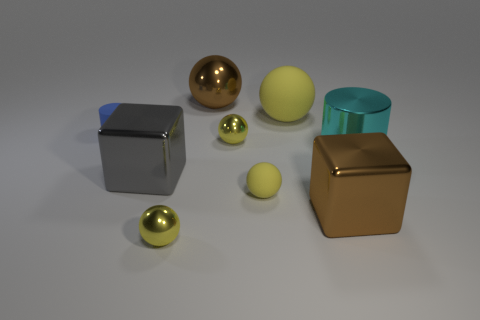How many yellow spheres must be subtracted to get 2 yellow spheres? 2 Subtract all red cylinders. How many yellow spheres are left? 4 Subtract all large matte balls. How many balls are left? 4 Add 1 big gray metal things. How many objects exist? 10 Subtract all brown balls. How many balls are left? 4 Subtract all cubes. How many objects are left? 7 Subtract all gray cylinders. Subtract all cyan spheres. How many cylinders are left? 2 Subtract all tiny yellow blocks. Subtract all large brown cubes. How many objects are left? 8 Add 1 gray metallic blocks. How many gray metallic blocks are left? 2 Add 4 spheres. How many spheres exist? 9 